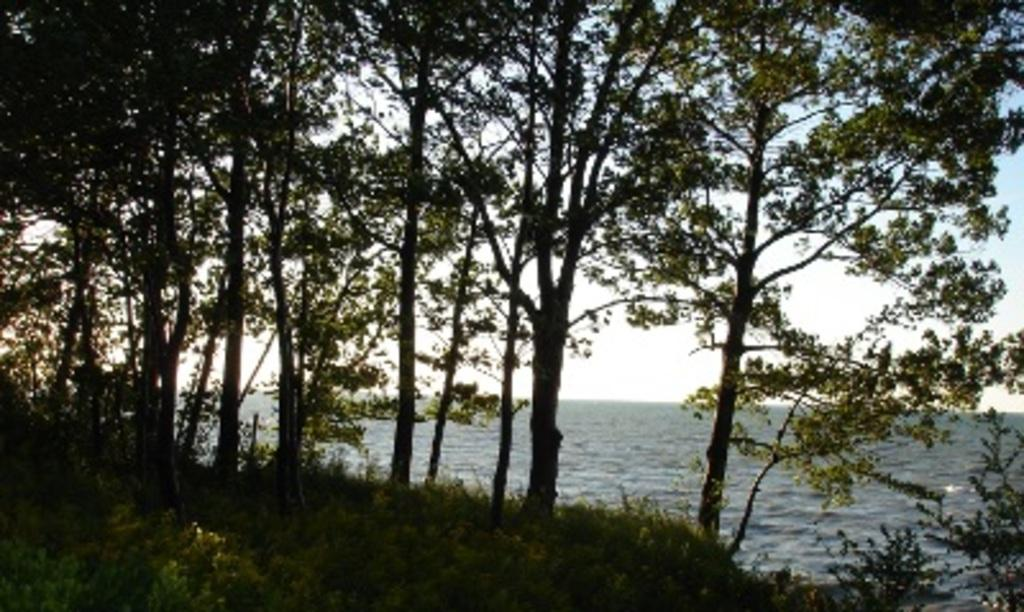What type of living organisms can be seen in the image? Plants and trees are visible in the image. What color are the plants in the image? The plants are green in color. What color are the trees in the image? The trees are green and black in color. What natural element can be seen in the image besides plants and trees? Water is visible in the image. What part of the natural environment is visible in the image? The sky is visible in the image. Can you tell me how many chickens are in the image? There are no chickens present in the image; it features plants, trees, water, and the sky. What type of glove is the actor wearing in the image? There is no actor or glove present in the image. 